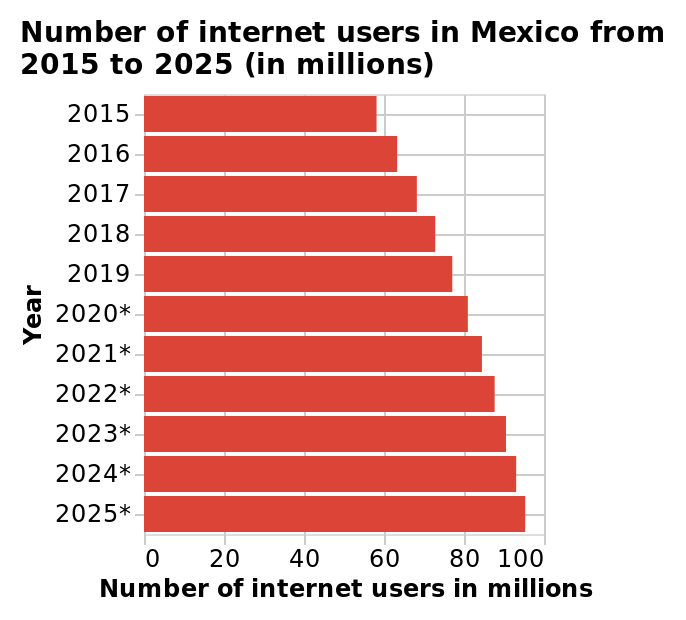<image>
What is the name of this bar plot?  The bar plot is named "Number of internet users in Mexico from 2015 to 2025 (in millions)". How does the number of users evolve during the years?  The number of users gradually grows up during the years. 